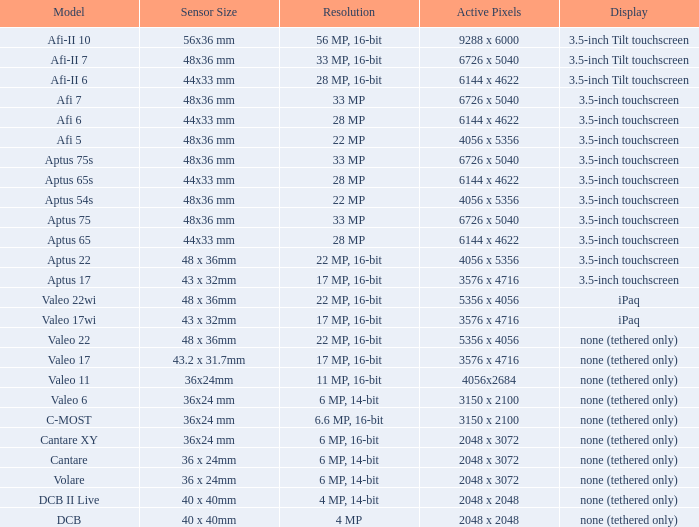What is the picture quality of the camera possessing 6726 x 5040 pixels and a model of afi 7? 33 MP. 